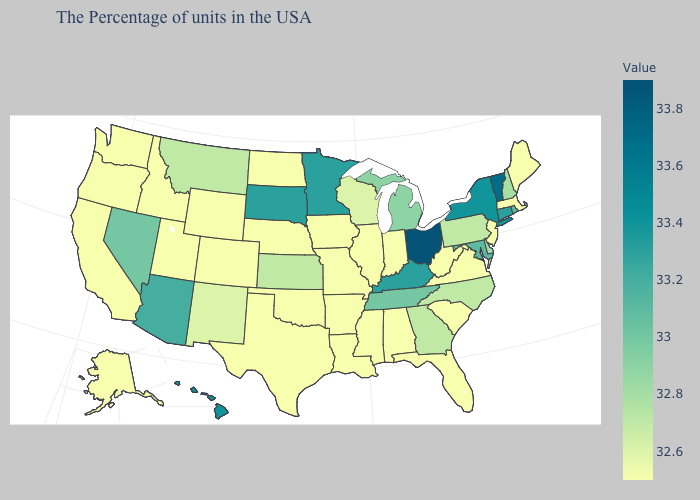Which states have the lowest value in the West?
Answer briefly. Wyoming, Colorado, Utah, Idaho, California, Washington, Oregon, Alaska. Does the map have missing data?
Write a very short answer. No. Does Oklahoma have the lowest value in the South?
Be succinct. Yes. Is the legend a continuous bar?
Keep it brief. Yes. Does the map have missing data?
Concise answer only. No. Which states have the lowest value in the USA?
Answer briefly. Maine, Massachusetts, New Jersey, Virginia, South Carolina, West Virginia, Florida, Indiana, Alabama, Illinois, Mississippi, Louisiana, Missouri, Arkansas, Iowa, Nebraska, Oklahoma, Texas, North Dakota, Wyoming, Colorado, Utah, Idaho, California, Washington, Oregon, Alaska. Which states have the lowest value in the USA?
Give a very brief answer. Maine, Massachusetts, New Jersey, Virginia, South Carolina, West Virginia, Florida, Indiana, Alabama, Illinois, Mississippi, Louisiana, Missouri, Arkansas, Iowa, Nebraska, Oklahoma, Texas, North Dakota, Wyoming, Colorado, Utah, Idaho, California, Washington, Oregon, Alaska. Does Minnesota have a higher value than North Dakota?
Write a very short answer. Yes. Does Mississippi have the highest value in the USA?
Answer briefly. No. 